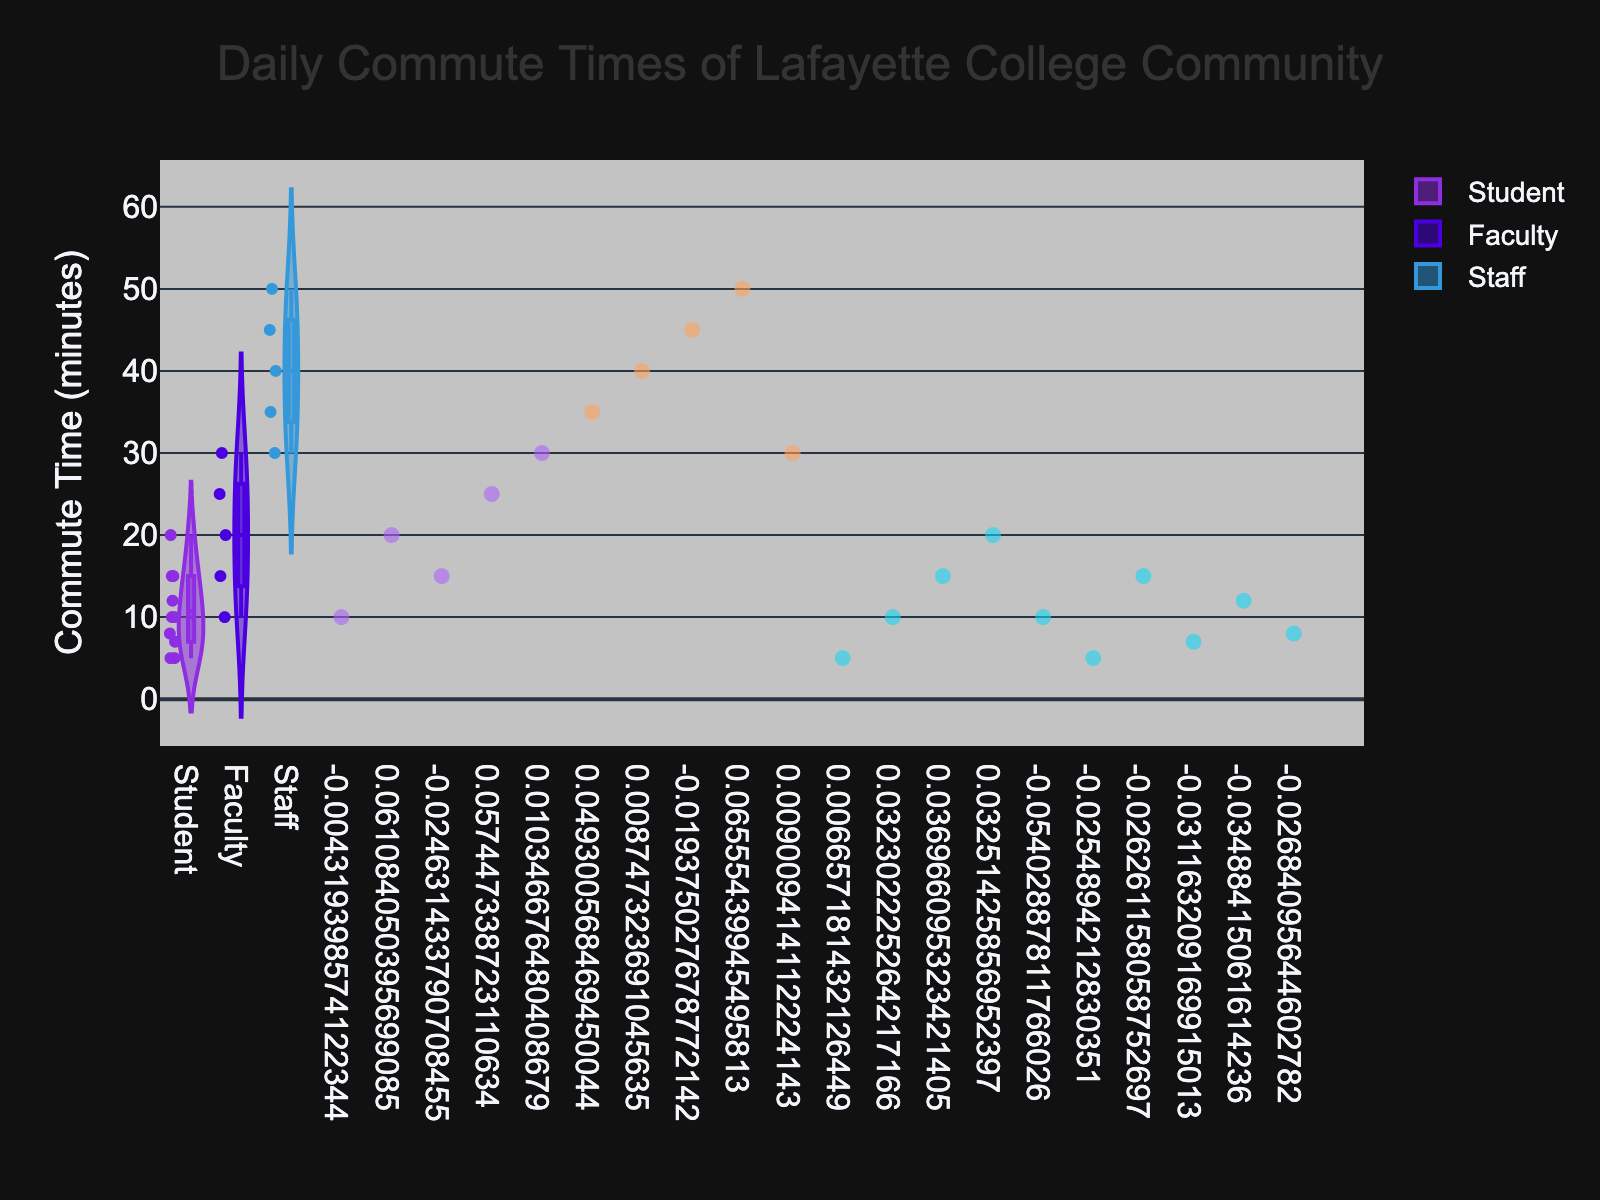What's the title of the figure? The title is presented at the top of the figure and usually summarizes what the figure is about.
Answer: Daily Commute Times of Lafayette College Community What does the y-axis represent? The y-axis is labeled with "Commute Time (minutes)," indicating that it represents the commute time in minutes.
Answer: Commute Time (minutes) What roles are compared in the figure? The x-axis has labels that categorize the data, and the roles listed are "Student," "Faculty," and "Staff."
Answer: Student, Faculty, Staff Which group has the longest median commute time? The figure uses box plots within the violins, where the median is marked as a line inside the box. The Staff group has the longest median commute time.
Answer: Staff How do the commute times of Students compare to those of Faculty? By observing the violin plots, the Students have generally shorter commute times compared to Faculty. The range of commute times for Students is mostly below 20 minutes, while many Faculty have commute times up to 30 minutes.
Answer: Students have shorter commute times compared to Faculty What is the range of commute times for the Faculty? The violin plot for Faculty extends from 10 to 30 minutes, showing the range of commute times.
Answer: 10 to 30 minutes Which role shows the most variability in commute times? Variability can be assessed by looking at the width and spread of the violin plots. The Staff has the widest and most spread out plot, indicating the most variability in commute times.
Answer: Staff Are there any outliers in the Staff commute times? The Staff violin plot doesn't have any data points significantly outside the main distribution, indicating no outliers are easily visible.
Answer: No What is the average commute time for Students? The average can be reasoned by looking at the distribution of data points and the density within the violin plot for Students, which centers around 10 minutes.
Answer: Around 10 minutes Which role has the highest individual commute time recorded? By observing the individual data points, the highest commute time is recorded in the Staff group at 50 minutes.
Answer: Staff 